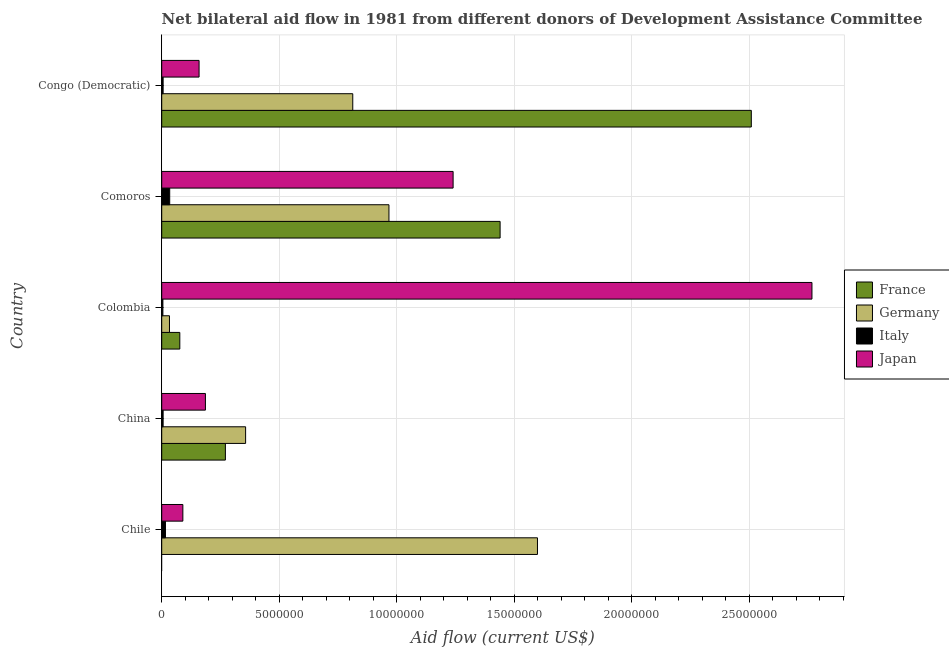How many different coloured bars are there?
Give a very brief answer. 4. Are the number of bars per tick equal to the number of legend labels?
Your response must be concise. No. Are the number of bars on each tick of the Y-axis equal?
Make the answer very short. No. How many bars are there on the 3rd tick from the bottom?
Provide a succinct answer. 4. What is the label of the 4th group of bars from the top?
Keep it short and to the point. China. In how many cases, is the number of bars for a given country not equal to the number of legend labels?
Your answer should be compact. 1. What is the amount of aid given by italy in China?
Give a very brief answer. 6.00e+04. Across all countries, what is the maximum amount of aid given by france?
Provide a short and direct response. 2.51e+07. Across all countries, what is the minimum amount of aid given by france?
Your answer should be compact. 0. In which country was the amount of aid given by france maximum?
Your response must be concise. Congo (Democratic). What is the total amount of aid given by france in the graph?
Your answer should be very brief. 4.30e+07. What is the difference between the amount of aid given by germany in Colombia and that in Comoros?
Make the answer very short. -9.34e+06. What is the difference between the amount of aid given by germany in China and the amount of aid given by japan in Comoros?
Ensure brevity in your answer.  -8.83e+06. What is the average amount of aid given by italy per country?
Ensure brevity in your answer.  1.34e+05. What is the difference between the amount of aid given by germany and amount of aid given by japan in Chile?
Your answer should be compact. 1.51e+07. In how many countries, is the amount of aid given by germany greater than 16000000 US$?
Provide a succinct answer. 0. What is the ratio of the amount of aid given by germany in China to that in Congo (Democratic)?
Offer a very short reply. 0.44. What is the difference between the highest and the second highest amount of aid given by germany?
Ensure brevity in your answer.  6.32e+06. What is the difference between the highest and the lowest amount of aid given by italy?
Offer a very short reply. 2.90e+05. In how many countries, is the amount of aid given by germany greater than the average amount of aid given by germany taken over all countries?
Provide a succinct answer. 3. Is it the case that in every country, the sum of the amount of aid given by france and amount of aid given by japan is greater than the sum of amount of aid given by italy and amount of aid given by germany?
Make the answer very short. No. Is it the case that in every country, the sum of the amount of aid given by france and amount of aid given by germany is greater than the amount of aid given by italy?
Your response must be concise. Yes. Are the values on the major ticks of X-axis written in scientific E-notation?
Offer a very short reply. No. Does the graph contain any zero values?
Your answer should be compact. Yes. Does the graph contain grids?
Make the answer very short. Yes. Where does the legend appear in the graph?
Offer a terse response. Center right. What is the title of the graph?
Provide a short and direct response. Net bilateral aid flow in 1981 from different donors of Development Assistance Committee. What is the label or title of the Y-axis?
Provide a short and direct response. Country. What is the Aid flow (current US$) of France in Chile?
Provide a succinct answer. 0. What is the Aid flow (current US$) of Germany in Chile?
Ensure brevity in your answer.  1.60e+07. What is the Aid flow (current US$) of France in China?
Offer a very short reply. 2.71e+06. What is the Aid flow (current US$) in Germany in China?
Give a very brief answer. 3.57e+06. What is the Aid flow (current US$) of Japan in China?
Keep it short and to the point. 1.86e+06. What is the Aid flow (current US$) of France in Colombia?
Provide a short and direct response. 7.70e+05. What is the Aid flow (current US$) of Italy in Colombia?
Keep it short and to the point. 5.00e+04. What is the Aid flow (current US$) of Japan in Colombia?
Give a very brief answer. 2.77e+07. What is the Aid flow (current US$) in France in Comoros?
Your answer should be very brief. 1.44e+07. What is the Aid flow (current US$) in Germany in Comoros?
Provide a short and direct response. 9.67e+06. What is the Aid flow (current US$) in Italy in Comoros?
Your response must be concise. 3.40e+05. What is the Aid flow (current US$) in Japan in Comoros?
Your response must be concise. 1.24e+07. What is the Aid flow (current US$) in France in Congo (Democratic)?
Give a very brief answer. 2.51e+07. What is the Aid flow (current US$) in Germany in Congo (Democratic)?
Your answer should be compact. 8.13e+06. What is the Aid flow (current US$) of Japan in Congo (Democratic)?
Keep it short and to the point. 1.59e+06. Across all countries, what is the maximum Aid flow (current US$) in France?
Your answer should be very brief. 2.51e+07. Across all countries, what is the maximum Aid flow (current US$) in Germany?
Give a very brief answer. 1.60e+07. Across all countries, what is the maximum Aid flow (current US$) of Japan?
Offer a terse response. 2.77e+07. Across all countries, what is the minimum Aid flow (current US$) of France?
Give a very brief answer. 0. Across all countries, what is the minimum Aid flow (current US$) of Germany?
Make the answer very short. 3.30e+05. Across all countries, what is the minimum Aid flow (current US$) in Italy?
Offer a very short reply. 5.00e+04. What is the total Aid flow (current US$) of France in the graph?
Offer a terse response. 4.30e+07. What is the total Aid flow (current US$) in Germany in the graph?
Offer a terse response. 3.77e+07. What is the total Aid flow (current US$) of Italy in the graph?
Provide a succinct answer. 6.70e+05. What is the total Aid flow (current US$) in Japan in the graph?
Offer a very short reply. 4.44e+07. What is the difference between the Aid flow (current US$) of Germany in Chile and that in China?
Provide a short and direct response. 1.24e+07. What is the difference between the Aid flow (current US$) of Japan in Chile and that in China?
Provide a succinct answer. -9.60e+05. What is the difference between the Aid flow (current US$) of Germany in Chile and that in Colombia?
Keep it short and to the point. 1.57e+07. What is the difference between the Aid flow (current US$) of Japan in Chile and that in Colombia?
Give a very brief answer. -2.68e+07. What is the difference between the Aid flow (current US$) of Germany in Chile and that in Comoros?
Provide a short and direct response. 6.32e+06. What is the difference between the Aid flow (current US$) of Japan in Chile and that in Comoros?
Provide a succinct answer. -1.15e+07. What is the difference between the Aid flow (current US$) in Germany in Chile and that in Congo (Democratic)?
Your answer should be compact. 7.86e+06. What is the difference between the Aid flow (current US$) of Italy in Chile and that in Congo (Democratic)?
Your answer should be very brief. 1.00e+05. What is the difference between the Aid flow (current US$) in Japan in Chile and that in Congo (Democratic)?
Give a very brief answer. -6.90e+05. What is the difference between the Aid flow (current US$) of France in China and that in Colombia?
Your answer should be compact. 1.94e+06. What is the difference between the Aid flow (current US$) in Germany in China and that in Colombia?
Your answer should be compact. 3.24e+06. What is the difference between the Aid flow (current US$) in Italy in China and that in Colombia?
Provide a short and direct response. 10000. What is the difference between the Aid flow (current US$) of Japan in China and that in Colombia?
Offer a very short reply. -2.58e+07. What is the difference between the Aid flow (current US$) in France in China and that in Comoros?
Your answer should be compact. -1.17e+07. What is the difference between the Aid flow (current US$) in Germany in China and that in Comoros?
Your answer should be compact. -6.10e+06. What is the difference between the Aid flow (current US$) of Italy in China and that in Comoros?
Offer a terse response. -2.80e+05. What is the difference between the Aid flow (current US$) in Japan in China and that in Comoros?
Your answer should be very brief. -1.05e+07. What is the difference between the Aid flow (current US$) of France in China and that in Congo (Democratic)?
Your answer should be very brief. -2.24e+07. What is the difference between the Aid flow (current US$) of Germany in China and that in Congo (Democratic)?
Make the answer very short. -4.56e+06. What is the difference between the Aid flow (current US$) of Italy in China and that in Congo (Democratic)?
Your answer should be compact. 0. What is the difference between the Aid flow (current US$) in Japan in China and that in Congo (Democratic)?
Offer a terse response. 2.70e+05. What is the difference between the Aid flow (current US$) in France in Colombia and that in Comoros?
Keep it short and to the point. -1.36e+07. What is the difference between the Aid flow (current US$) of Germany in Colombia and that in Comoros?
Offer a terse response. -9.34e+06. What is the difference between the Aid flow (current US$) in Japan in Colombia and that in Comoros?
Offer a terse response. 1.53e+07. What is the difference between the Aid flow (current US$) of France in Colombia and that in Congo (Democratic)?
Make the answer very short. -2.43e+07. What is the difference between the Aid flow (current US$) of Germany in Colombia and that in Congo (Democratic)?
Offer a terse response. -7.80e+06. What is the difference between the Aid flow (current US$) of Italy in Colombia and that in Congo (Democratic)?
Make the answer very short. -10000. What is the difference between the Aid flow (current US$) of Japan in Colombia and that in Congo (Democratic)?
Your response must be concise. 2.61e+07. What is the difference between the Aid flow (current US$) of France in Comoros and that in Congo (Democratic)?
Give a very brief answer. -1.07e+07. What is the difference between the Aid flow (current US$) in Germany in Comoros and that in Congo (Democratic)?
Your answer should be very brief. 1.54e+06. What is the difference between the Aid flow (current US$) in Japan in Comoros and that in Congo (Democratic)?
Your response must be concise. 1.08e+07. What is the difference between the Aid flow (current US$) of Germany in Chile and the Aid flow (current US$) of Italy in China?
Your response must be concise. 1.59e+07. What is the difference between the Aid flow (current US$) in Germany in Chile and the Aid flow (current US$) in Japan in China?
Keep it short and to the point. 1.41e+07. What is the difference between the Aid flow (current US$) in Italy in Chile and the Aid flow (current US$) in Japan in China?
Keep it short and to the point. -1.70e+06. What is the difference between the Aid flow (current US$) in Germany in Chile and the Aid flow (current US$) in Italy in Colombia?
Give a very brief answer. 1.59e+07. What is the difference between the Aid flow (current US$) of Germany in Chile and the Aid flow (current US$) of Japan in Colombia?
Keep it short and to the point. -1.17e+07. What is the difference between the Aid flow (current US$) of Italy in Chile and the Aid flow (current US$) of Japan in Colombia?
Ensure brevity in your answer.  -2.75e+07. What is the difference between the Aid flow (current US$) in Germany in Chile and the Aid flow (current US$) in Italy in Comoros?
Ensure brevity in your answer.  1.56e+07. What is the difference between the Aid flow (current US$) of Germany in Chile and the Aid flow (current US$) of Japan in Comoros?
Offer a very short reply. 3.59e+06. What is the difference between the Aid flow (current US$) of Italy in Chile and the Aid flow (current US$) of Japan in Comoros?
Your response must be concise. -1.22e+07. What is the difference between the Aid flow (current US$) in Germany in Chile and the Aid flow (current US$) in Italy in Congo (Democratic)?
Your answer should be compact. 1.59e+07. What is the difference between the Aid flow (current US$) in Germany in Chile and the Aid flow (current US$) in Japan in Congo (Democratic)?
Ensure brevity in your answer.  1.44e+07. What is the difference between the Aid flow (current US$) of Italy in Chile and the Aid flow (current US$) of Japan in Congo (Democratic)?
Your answer should be very brief. -1.43e+06. What is the difference between the Aid flow (current US$) in France in China and the Aid flow (current US$) in Germany in Colombia?
Ensure brevity in your answer.  2.38e+06. What is the difference between the Aid flow (current US$) of France in China and the Aid flow (current US$) of Italy in Colombia?
Give a very brief answer. 2.66e+06. What is the difference between the Aid flow (current US$) of France in China and the Aid flow (current US$) of Japan in Colombia?
Keep it short and to the point. -2.50e+07. What is the difference between the Aid flow (current US$) of Germany in China and the Aid flow (current US$) of Italy in Colombia?
Provide a short and direct response. 3.52e+06. What is the difference between the Aid flow (current US$) of Germany in China and the Aid flow (current US$) of Japan in Colombia?
Provide a succinct answer. -2.41e+07. What is the difference between the Aid flow (current US$) of Italy in China and the Aid flow (current US$) of Japan in Colombia?
Give a very brief answer. -2.76e+07. What is the difference between the Aid flow (current US$) in France in China and the Aid flow (current US$) in Germany in Comoros?
Offer a very short reply. -6.96e+06. What is the difference between the Aid flow (current US$) in France in China and the Aid flow (current US$) in Italy in Comoros?
Provide a short and direct response. 2.37e+06. What is the difference between the Aid flow (current US$) of France in China and the Aid flow (current US$) of Japan in Comoros?
Your answer should be very brief. -9.69e+06. What is the difference between the Aid flow (current US$) in Germany in China and the Aid flow (current US$) in Italy in Comoros?
Ensure brevity in your answer.  3.23e+06. What is the difference between the Aid flow (current US$) of Germany in China and the Aid flow (current US$) of Japan in Comoros?
Your answer should be very brief. -8.83e+06. What is the difference between the Aid flow (current US$) in Italy in China and the Aid flow (current US$) in Japan in Comoros?
Your answer should be very brief. -1.23e+07. What is the difference between the Aid flow (current US$) in France in China and the Aid flow (current US$) in Germany in Congo (Democratic)?
Offer a terse response. -5.42e+06. What is the difference between the Aid flow (current US$) in France in China and the Aid flow (current US$) in Italy in Congo (Democratic)?
Provide a short and direct response. 2.65e+06. What is the difference between the Aid flow (current US$) of France in China and the Aid flow (current US$) of Japan in Congo (Democratic)?
Make the answer very short. 1.12e+06. What is the difference between the Aid flow (current US$) of Germany in China and the Aid flow (current US$) of Italy in Congo (Democratic)?
Your answer should be compact. 3.51e+06. What is the difference between the Aid flow (current US$) in Germany in China and the Aid flow (current US$) in Japan in Congo (Democratic)?
Your answer should be very brief. 1.98e+06. What is the difference between the Aid flow (current US$) in Italy in China and the Aid flow (current US$) in Japan in Congo (Democratic)?
Make the answer very short. -1.53e+06. What is the difference between the Aid flow (current US$) in France in Colombia and the Aid flow (current US$) in Germany in Comoros?
Make the answer very short. -8.90e+06. What is the difference between the Aid flow (current US$) of France in Colombia and the Aid flow (current US$) of Italy in Comoros?
Provide a short and direct response. 4.30e+05. What is the difference between the Aid flow (current US$) of France in Colombia and the Aid flow (current US$) of Japan in Comoros?
Offer a very short reply. -1.16e+07. What is the difference between the Aid flow (current US$) of Germany in Colombia and the Aid flow (current US$) of Japan in Comoros?
Your answer should be compact. -1.21e+07. What is the difference between the Aid flow (current US$) of Italy in Colombia and the Aid flow (current US$) of Japan in Comoros?
Provide a short and direct response. -1.24e+07. What is the difference between the Aid flow (current US$) of France in Colombia and the Aid flow (current US$) of Germany in Congo (Democratic)?
Provide a short and direct response. -7.36e+06. What is the difference between the Aid flow (current US$) in France in Colombia and the Aid flow (current US$) in Italy in Congo (Democratic)?
Offer a very short reply. 7.10e+05. What is the difference between the Aid flow (current US$) of France in Colombia and the Aid flow (current US$) of Japan in Congo (Democratic)?
Keep it short and to the point. -8.20e+05. What is the difference between the Aid flow (current US$) of Germany in Colombia and the Aid flow (current US$) of Japan in Congo (Democratic)?
Offer a terse response. -1.26e+06. What is the difference between the Aid flow (current US$) of Italy in Colombia and the Aid flow (current US$) of Japan in Congo (Democratic)?
Your answer should be compact. -1.54e+06. What is the difference between the Aid flow (current US$) of France in Comoros and the Aid flow (current US$) of Germany in Congo (Democratic)?
Provide a short and direct response. 6.27e+06. What is the difference between the Aid flow (current US$) of France in Comoros and the Aid flow (current US$) of Italy in Congo (Democratic)?
Your answer should be very brief. 1.43e+07. What is the difference between the Aid flow (current US$) of France in Comoros and the Aid flow (current US$) of Japan in Congo (Democratic)?
Provide a short and direct response. 1.28e+07. What is the difference between the Aid flow (current US$) in Germany in Comoros and the Aid flow (current US$) in Italy in Congo (Democratic)?
Keep it short and to the point. 9.61e+06. What is the difference between the Aid flow (current US$) in Germany in Comoros and the Aid flow (current US$) in Japan in Congo (Democratic)?
Give a very brief answer. 8.08e+06. What is the difference between the Aid flow (current US$) of Italy in Comoros and the Aid flow (current US$) of Japan in Congo (Democratic)?
Your answer should be compact. -1.25e+06. What is the average Aid flow (current US$) of France per country?
Your answer should be compact. 8.59e+06. What is the average Aid flow (current US$) in Germany per country?
Make the answer very short. 7.54e+06. What is the average Aid flow (current US$) in Italy per country?
Give a very brief answer. 1.34e+05. What is the average Aid flow (current US$) in Japan per country?
Your answer should be very brief. 8.88e+06. What is the difference between the Aid flow (current US$) of Germany and Aid flow (current US$) of Italy in Chile?
Make the answer very short. 1.58e+07. What is the difference between the Aid flow (current US$) of Germany and Aid flow (current US$) of Japan in Chile?
Provide a short and direct response. 1.51e+07. What is the difference between the Aid flow (current US$) of Italy and Aid flow (current US$) of Japan in Chile?
Provide a short and direct response. -7.40e+05. What is the difference between the Aid flow (current US$) in France and Aid flow (current US$) in Germany in China?
Make the answer very short. -8.60e+05. What is the difference between the Aid flow (current US$) of France and Aid flow (current US$) of Italy in China?
Your answer should be compact. 2.65e+06. What is the difference between the Aid flow (current US$) of France and Aid flow (current US$) of Japan in China?
Keep it short and to the point. 8.50e+05. What is the difference between the Aid flow (current US$) in Germany and Aid flow (current US$) in Italy in China?
Ensure brevity in your answer.  3.51e+06. What is the difference between the Aid flow (current US$) in Germany and Aid flow (current US$) in Japan in China?
Provide a succinct answer. 1.71e+06. What is the difference between the Aid flow (current US$) in Italy and Aid flow (current US$) in Japan in China?
Your response must be concise. -1.80e+06. What is the difference between the Aid flow (current US$) in France and Aid flow (current US$) in Italy in Colombia?
Offer a very short reply. 7.20e+05. What is the difference between the Aid flow (current US$) of France and Aid flow (current US$) of Japan in Colombia?
Your answer should be compact. -2.69e+07. What is the difference between the Aid flow (current US$) of Germany and Aid flow (current US$) of Italy in Colombia?
Your answer should be compact. 2.80e+05. What is the difference between the Aid flow (current US$) of Germany and Aid flow (current US$) of Japan in Colombia?
Your answer should be compact. -2.73e+07. What is the difference between the Aid flow (current US$) in Italy and Aid flow (current US$) in Japan in Colombia?
Ensure brevity in your answer.  -2.76e+07. What is the difference between the Aid flow (current US$) in France and Aid flow (current US$) in Germany in Comoros?
Offer a very short reply. 4.73e+06. What is the difference between the Aid flow (current US$) in France and Aid flow (current US$) in Italy in Comoros?
Provide a succinct answer. 1.41e+07. What is the difference between the Aid flow (current US$) in France and Aid flow (current US$) in Japan in Comoros?
Your response must be concise. 2.00e+06. What is the difference between the Aid flow (current US$) of Germany and Aid flow (current US$) of Italy in Comoros?
Provide a short and direct response. 9.33e+06. What is the difference between the Aid flow (current US$) of Germany and Aid flow (current US$) of Japan in Comoros?
Provide a short and direct response. -2.73e+06. What is the difference between the Aid flow (current US$) of Italy and Aid flow (current US$) of Japan in Comoros?
Provide a short and direct response. -1.21e+07. What is the difference between the Aid flow (current US$) in France and Aid flow (current US$) in Germany in Congo (Democratic)?
Offer a terse response. 1.70e+07. What is the difference between the Aid flow (current US$) in France and Aid flow (current US$) in Italy in Congo (Democratic)?
Your response must be concise. 2.50e+07. What is the difference between the Aid flow (current US$) in France and Aid flow (current US$) in Japan in Congo (Democratic)?
Your answer should be very brief. 2.35e+07. What is the difference between the Aid flow (current US$) in Germany and Aid flow (current US$) in Italy in Congo (Democratic)?
Give a very brief answer. 8.07e+06. What is the difference between the Aid flow (current US$) of Germany and Aid flow (current US$) of Japan in Congo (Democratic)?
Provide a succinct answer. 6.54e+06. What is the difference between the Aid flow (current US$) of Italy and Aid flow (current US$) of Japan in Congo (Democratic)?
Your answer should be very brief. -1.53e+06. What is the ratio of the Aid flow (current US$) of Germany in Chile to that in China?
Make the answer very short. 4.48. What is the ratio of the Aid flow (current US$) in Italy in Chile to that in China?
Your answer should be compact. 2.67. What is the ratio of the Aid flow (current US$) of Japan in Chile to that in China?
Your answer should be very brief. 0.48. What is the ratio of the Aid flow (current US$) in Germany in Chile to that in Colombia?
Give a very brief answer. 48.45. What is the ratio of the Aid flow (current US$) in Italy in Chile to that in Colombia?
Your answer should be very brief. 3.2. What is the ratio of the Aid flow (current US$) in Japan in Chile to that in Colombia?
Give a very brief answer. 0.03. What is the ratio of the Aid flow (current US$) in Germany in Chile to that in Comoros?
Provide a short and direct response. 1.65. What is the ratio of the Aid flow (current US$) in Italy in Chile to that in Comoros?
Keep it short and to the point. 0.47. What is the ratio of the Aid flow (current US$) in Japan in Chile to that in Comoros?
Give a very brief answer. 0.07. What is the ratio of the Aid flow (current US$) of Germany in Chile to that in Congo (Democratic)?
Your response must be concise. 1.97. What is the ratio of the Aid flow (current US$) of Italy in Chile to that in Congo (Democratic)?
Your response must be concise. 2.67. What is the ratio of the Aid flow (current US$) of Japan in Chile to that in Congo (Democratic)?
Provide a short and direct response. 0.57. What is the ratio of the Aid flow (current US$) of France in China to that in Colombia?
Make the answer very short. 3.52. What is the ratio of the Aid flow (current US$) of Germany in China to that in Colombia?
Keep it short and to the point. 10.82. What is the ratio of the Aid flow (current US$) of Japan in China to that in Colombia?
Keep it short and to the point. 0.07. What is the ratio of the Aid flow (current US$) of France in China to that in Comoros?
Make the answer very short. 0.19. What is the ratio of the Aid flow (current US$) in Germany in China to that in Comoros?
Keep it short and to the point. 0.37. What is the ratio of the Aid flow (current US$) of Italy in China to that in Comoros?
Make the answer very short. 0.18. What is the ratio of the Aid flow (current US$) in France in China to that in Congo (Democratic)?
Offer a very short reply. 0.11. What is the ratio of the Aid flow (current US$) of Germany in China to that in Congo (Democratic)?
Your answer should be compact. 0.44. What is the ratio of the Aid flow (current US$) in Italy in China to that in Congo (Democratic)?
Keep it short and to the point. 1. What is the ratio of the Aid flow (current US$) of Japan in China to that in Congo (Democratic)?
Your response must be concise. 1.17. What is the ratio of the Aid flow (current US$) of France in Colombia to that in Comoros?
Keep it short and to the point. 0.05. What is the ratio of the Aid flow (current US$) in Germany in Colombia to that in Comoros?
Your response must be concise. 0.03. What is the ratio of the Aid flow (current US$) in Italy in Colombia to that in Comoros?
Your answer should be compact. 0.15. What is the ratio of the Aid flow (current US$) of Japan in Colombia to that in Comoros?
Provide a short and direct response. 2.23. What is the ratio of the Aid flow (current US$) of France in Colombia to that in Congo (Democratic)?
Your response must be concise. 0.03. What is the ratio of the Aid flow (current US$) in Germany in Colombia to that in Congo (Democratic)?
Give a very brief answer. 0.04. What is the ratio of the Aid flow (current US$) of Japan in Colombia to that in Congo (Democratic)?
Ensure brevity in your answer.  17.4. What is the ratio of the Aid flow (current US$) of France in Comoros to that in Congo (Democratic)?
Provide a short and direct response. 0.57. What is the ratio of the Aid flow (current US$) in Germany in Comoros to that in Congo (Democratic)?
Provide a succinct answer. 1.19. What is the ratio of the Aid flow (current US$) in Italy in Comoros to that in Congo (Democratic)?
Offer a very short reply. 5.67. What is the ratio of the Aid flow (current US$) in Japan in Comoros to that in Congo (Democratic)?
Your answer should be compact. 7.8. What is the difference between the highest and the second highest Aid flow (current US$) in France?
Make the answer very short. 1.07e+07. What is the difference between the highest and the second highest Aid flow (current US$) of Germany?
Provide a short and direct response. 6.32e+06. What is the difference between the highest and the second highest Aid flow (current US$) of Italy?
Your answer should be compact. 1.80e+05. What is the difference between the highest and the second highest Aid flow (current US$) of Japan?
Ensure brevity in your answer.  1.53e+07. What is the difference between the highest and the lowest Aid flow (current US$) in France?
Offer a terse response. 2.51e+07. What is the difference between the highest and the lowest Aid flow (current US$) of Germany?
Give a very brief answer. 1.57e+07. What is the difference between the highest and the lowest Aid flow (current US$) of Italy?
Offer a terse response. 2.90e+05. What is the difference between the highest and the lowest Aid flow (current US$) of Japan?
Your answer should be very brief. 2.68e+07. 